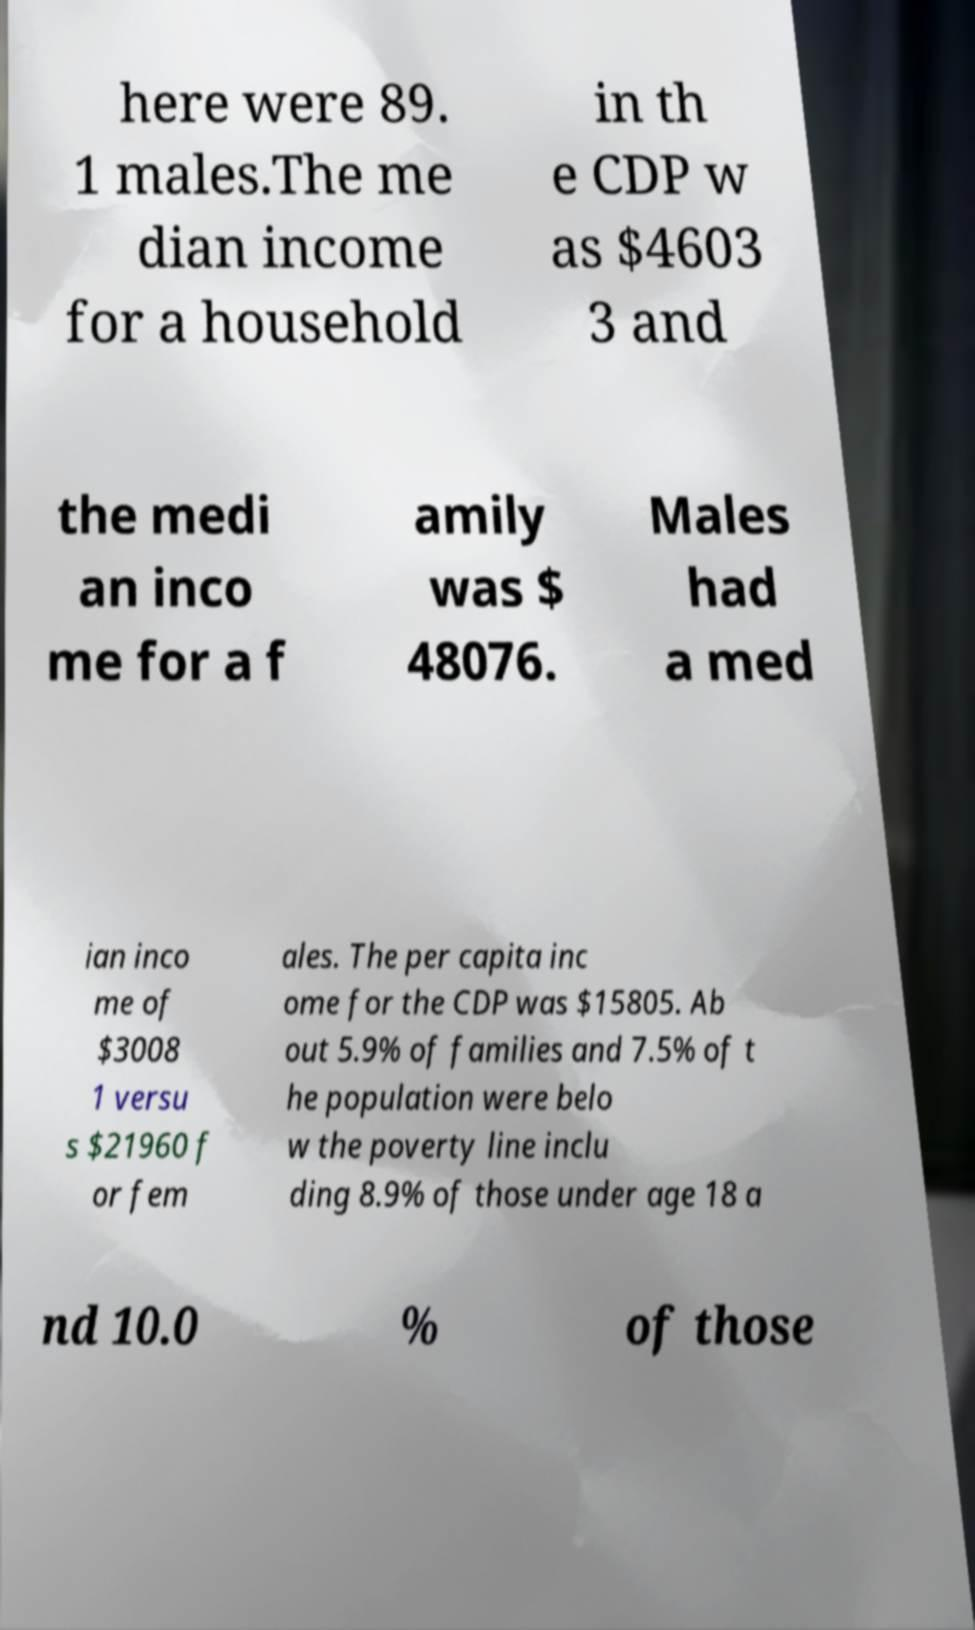Can you read and provide the text displayed in the image?This photo seems to have some interesting text. Can you extract and type it out for me? here were 89. 1 males.The me dian income for a household in th e CDP w as $4603 3 and the medi an inco me for a f amily was $ 48076. Males had a med ian inco me of $3008 1 versu s $21960 f or fem ales. The per capita inc ome for the CDP was $15805. Ab out 5.9% of families and 7.5% of t he population were belo w the poverty line inclu ding 8.9% of those under age 18 a nd 10.0 % of those 